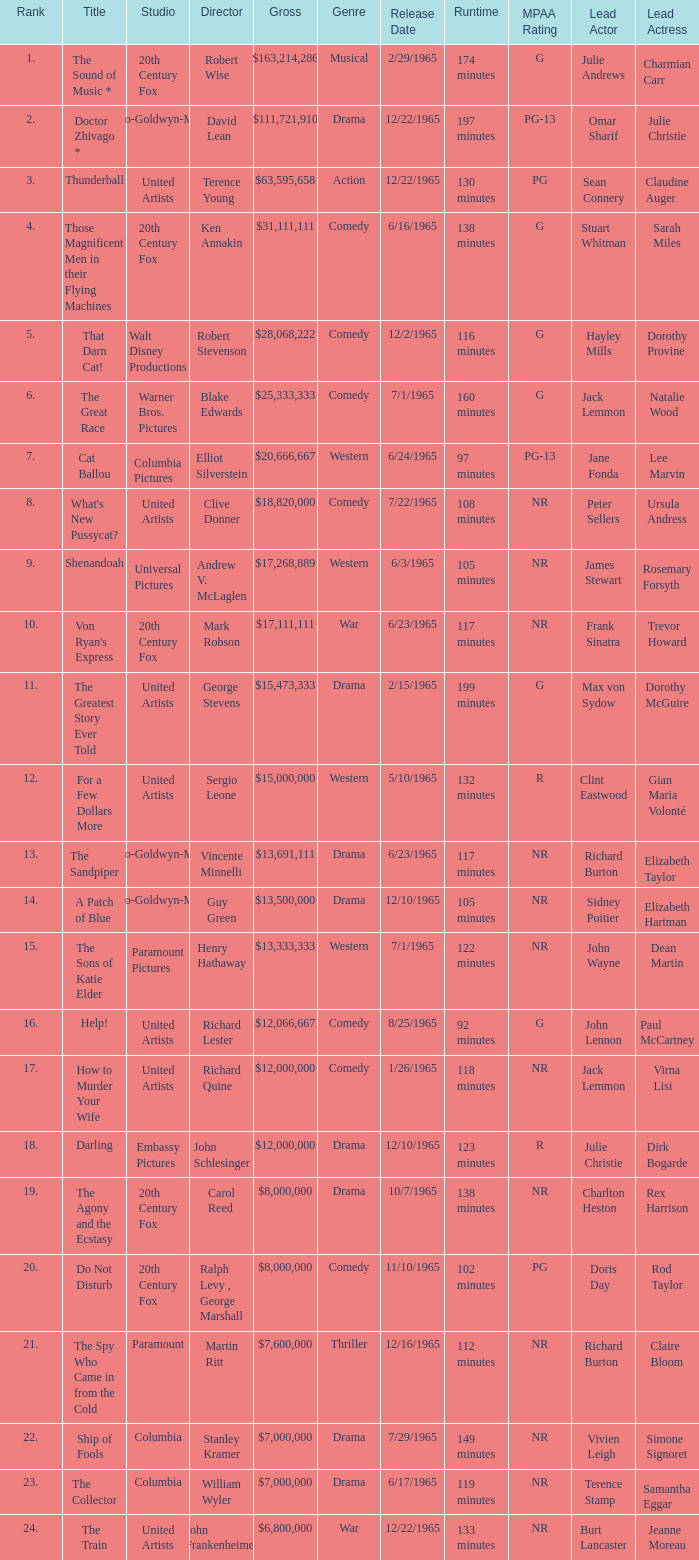What is the highest Rank, when Director is "Henry Hathaway"? 15.0. 